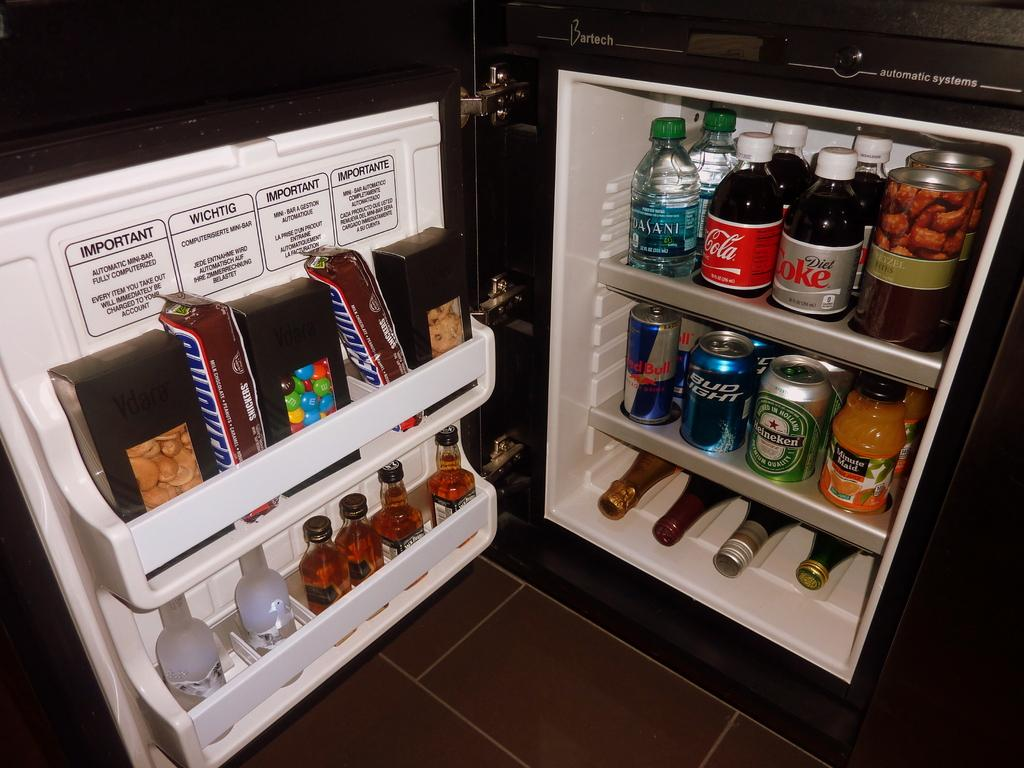<image>
Render a clear and concise summary of the photo. the refrigerator is full of snickers, soda, beer and wine 